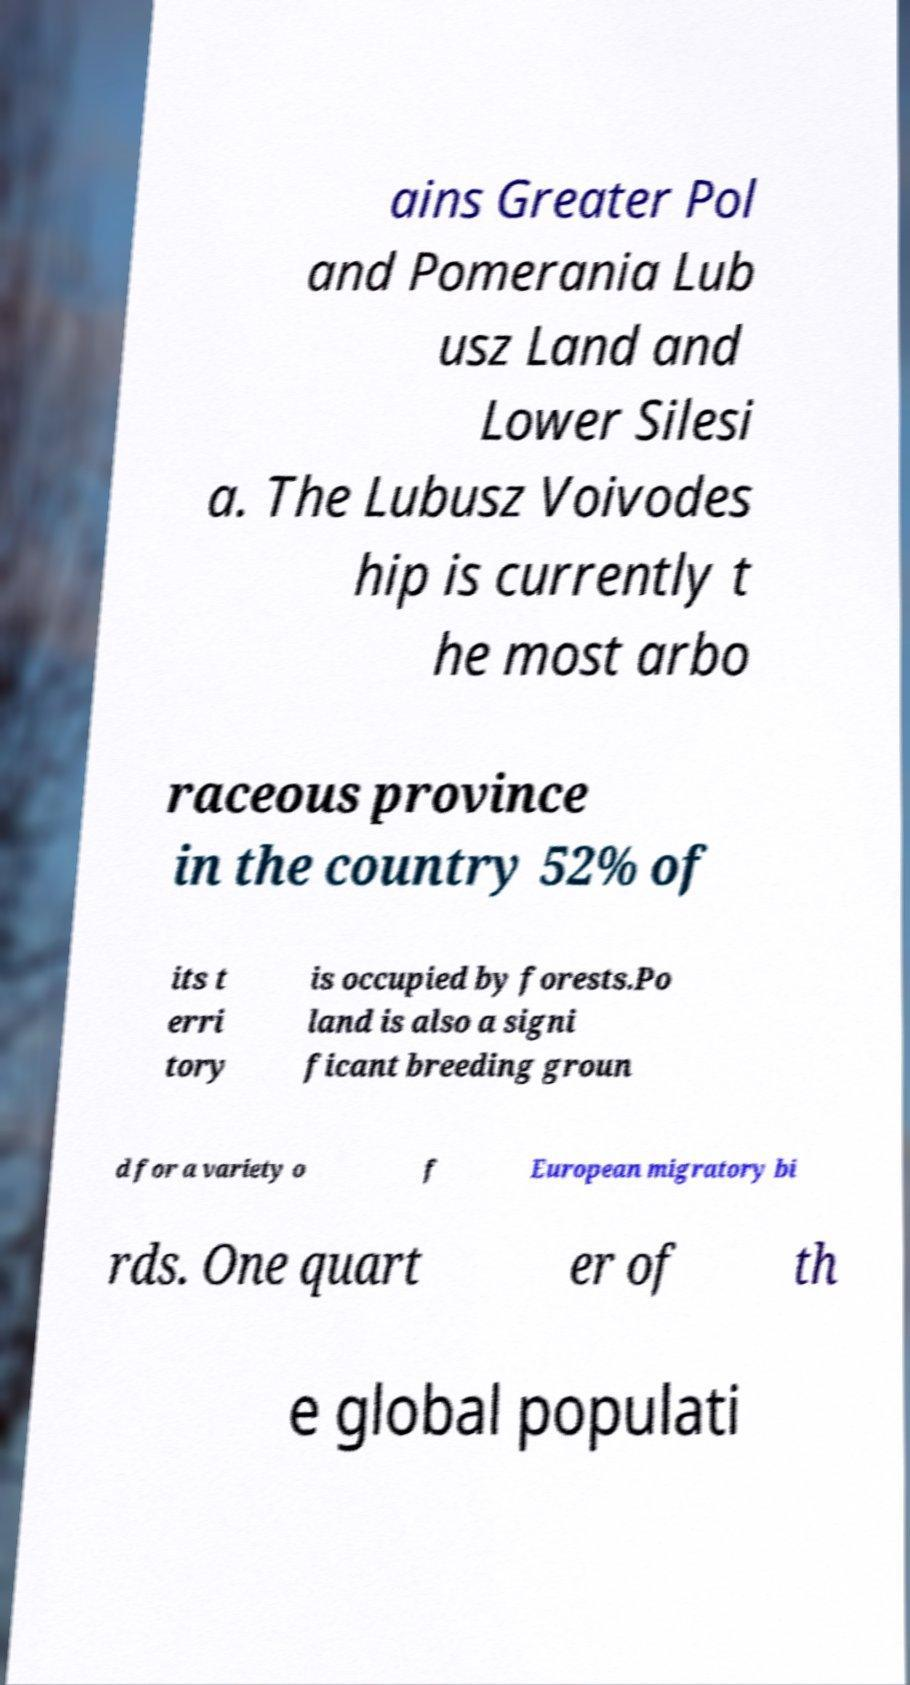For documentation purposes, I need the text within this image transcribed. Could you provide that? ains Greater Pol and Pomerania Lub usz Land and Lower Silesi a. The Lubusz Voivodes hip is currently t he most arbo raceous province in the country 52% of its t erri tory is occupied by forests.Po land is also a signi ficant breeding groun d for a variety o f European migratory bi rds. One quart er of th e global populati 